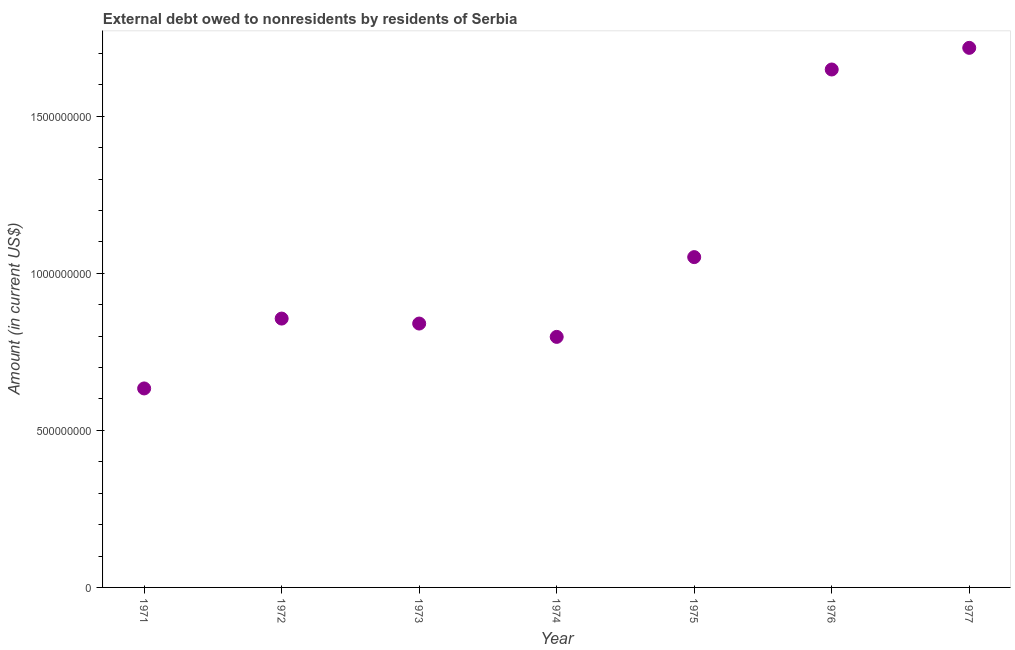What is the debt in 1972?
Keep it short and to the point. 8.56e+08. Across all years, what is the maximum debt?
Your answer should be compact. 1.72e+09. Across all years, what is the minimum debt?
Provide a succinct answer. 6.33e+08. What is the sum of the debt?
Offer a very short reply. 7.54e+09. What is the difference between the debt in 1972 and 1976?
Provide a succinct answer. -7.93e+08. What is the average debt per year?
Ensure brevity in your answer.  1.08e+09. What is the median debt?
Offer a terse response. 8.56e+08. In how many years, is the debt greater than 200000000 US$?
Make the answer very short. 7. Do a majority of the years between 1977 and 1976 (inclusive) have debt greater than 1300000000 US$?
Your response must be concise. No. What is the ratio of the debt in 1971 to that in 1977?
Offer a very short reply. 0.37. Is the debt in 1973 less than that in 1976?
Keep it short and to the point. Yes. Is the difference between the debt in 1975 and 1977 greater than the difference between any two years?
Provide a short and direct response. No. What is the difference between the highest and the second highest debt?
Keep it short and to the point. 6.89e+07. Is the sum of the debt in 1971 and 1972 greater than the maximum debt across all years?
Your answer should be very brief. No. What is the difference between the highest and the lowest debt?
Offer a terse response. 1.08e+09. In how many years, is the debt greater than the average debt taken over all years?
Offer a very short reply. 2. Does the graph contain any zero values?
Give a very brief answer. No. Does the graph contain grids?
Keep it short and to the point. No. What is the title of the graph?
Your answer should be compact. External debt owed to nonresidents by residents of Serbia. What is the label or title of the X-axis?
Your answer should be compact. Year. What is the label or title of the Y-axis?
Keep it short and to the point. Amount (in current US$). What is the Amount (in current US$) in 1971?
Provide a succinct answer. 6.33e+08. What is the Amount (in current US$) in 1972?
Offer a terse response. 8.56e+08. What is the Amount (in current US$) in 1973?
Give a very brief answer. 8.40e+08. What is the Amount (in current US$) in 1974?
Ensure brevity in your answer.  7.98e+08. What is the Amount (in current US$) in 1975?
Your answer should be very brief. 1.05e+09. What is the Amount (in current US$) in 1976?
Make the answer very short. 1.65e+09. What is the Amount (in current US$) in 1977?
Provide a succinct answer. 1.72e+09. What is the difference between the Amount (in current US$) in 1971 and 1972?
Provide a short and direct response. -2.22e+08. What is the difference between the Amount (in current US$) in 1971 and 1973?
Ensure brevity in your answer.  -2.07e+08. What is the difference between the Amount (in current US$) in 1971 and 1974?
Offer a terse response. -1.64e+08. What is the difference between the Amount (in current US$) in 1971 and 1975?
Make the answer very short. -4.18e+08. What is the difference between the Amount (in current US$) in 1971 and 1976?
Make the answer very short. -1.02e+09. What is the difference between the Amount (in current US$) in 1971 and 1977?
Your answer should be very brief. -1.08e+09. What is the difference between the Amount (in current US$) in 1972 and 1973?
Give a very brief answer. 1.58e+07. What is the difference between the Amount (in current US$) in 1972 and 1974?
Your answer should be compact. 5.83e+07. What is the difference between the Amount (in current US$) in 1972 and 1975?
Offer a terse response. -1.96e+08. What is the difference between the Amount (in current US$) in 1972 and 1976?
Your answer should be compact. -7.93e+08. What is the difference between the Amount (in current US$) in 1972 and 1977?
Provide a succinct answer. -8.62e+08. What is the difference between the Amount (in current US$) in 1973 and 1974?
Give a very brief answer. 4.24e+07. What is the difference between the Amount (in current US$) in 1973 and 1975?
Ensure brevity in your answer.  -2.11e+08. What is the difference between the Amount (in current US$) in 1973 and 1976?
Offer a very short reply. -8.09e+08. What is the difference between the Amount (in current US$) in 1973 and 1977?
Provide a short and direct response. -8.78e+08. What is the difference between the Amount (in current US$) in 1974 and 1975?
Provide a short and direct response. -2.54e+08. What is the difference between the Amount (in current US$) in 1974 and 1976?
Offer a terse response. -8.51e+08. What is the difference between the Amount (in current US$) in 1974 and 1977?
Your answer should be very brief. -9.20e+08. What is the difference between the Amount (in current US$) in 1975 and 1976?
Offer a terse response. -5.97e+08. What is the difference between the Amount (in current US$) in 1975 and 1977?
Keep it short and to the point. -6.66e+08. What is the difference between the Amount (in current US$) in 1976 and 1977?
Your answer should be compact. -6.89e+07. What is the ratio of the Amount (in current US$) in 1971 to that in 1972?
Make the answer very short. 0.74. What is the ratio of the Amount (in current US$) in 1971 to that in 1973?
Offer a terse response. 0.75. What is the ratio of the Amount (in current US$) in 1971 to that in 1974?
Give a very brief answer. 0.79. What is the ratio of the Amount (in current US$) in 1971 to that in 1975?
Offer a terse response. 0.6. What is the ratio of the Amount (in current US$) in 1971 to that in 1976?
Provide a short and direct response. 0.38. What is the ratio of the Amount (in current US$) in 1971 to that in 1977?
Your answer should be compact. 0.37. What is the ratio of the Amount (in current US$) in 1972 to that in 1973?
Keep it short and to the point. 1.02. What is the ratio of the Amount (in current US$) in 1972 to that in 1974?
Provide a succinct answer. 1.07. What is the ratio of the Amount (in current US$) in 1972 to that in 1975?
Your response must be concise. 0.81. What is the ratio of the Amount (in current US$) in 1972 to that in 1976?
Make the answer very short. 0.52. What is the ratio of the Amount (in current US$) in 1972 to that in 1977?
Make the answer very short. 0.5. What is the ratio of the Amount (in current US$) in 1973 to that in 1974?
Provide a short and direct response. 1.05. What is the ratio of the Amount (in current US$) in 1973 to that in 1975?
Keep it short and to the point. 0.8. What is the ratio of the Amount (in current US$) in 1973 to that in 1976?
Give a very brief answer. 0.51. What is the ratio of the Amount (in current US$) in 1973 to that in 1977?
Provide a short and direct response. 0.49. What is the ratio of the Amount (in current US$) in 1974 to that in 1975?
Give a very brief answer. 0.76. What is the ratio of the Amount (in current US$) in 1974 to that in 1976?
Ensure brevity in your answer.  0.48. What is the ratio of the Amount (in current US$) in 1974 to that in 1977?
Provide a short and direct response. 0.46. What is the ratio of the Amount (in current US$) in 1975 to that in 1976?
Provide a succinct answer. 0.64. What is the ratio of the Amount (in current US$) in 1975 to that in 1977?
Your response must be concise. 0.61. 